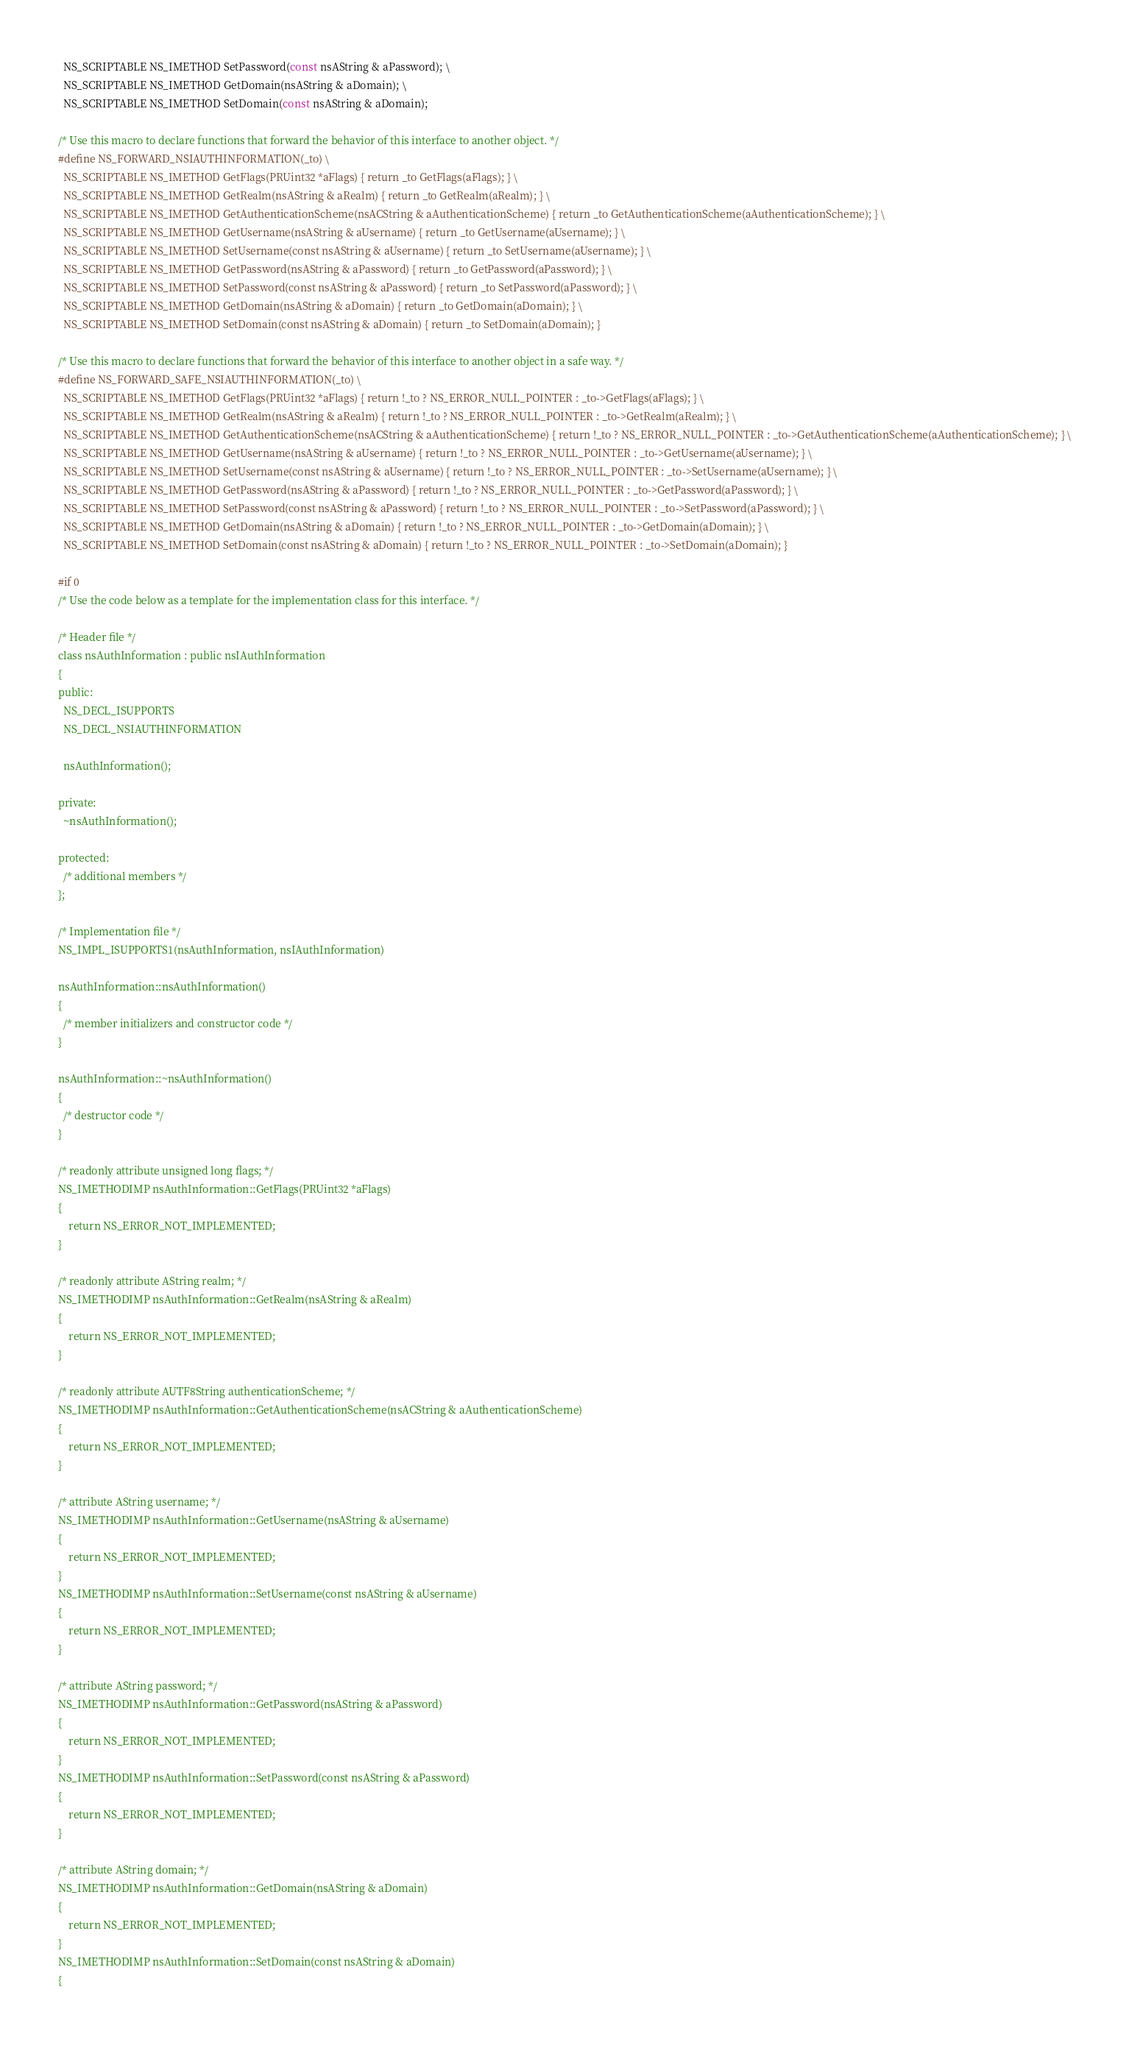Convert code to text. <code><loc_0><loc_0><loc_500><loc_500><_C_>  NS_SCRIPTABLE NS_IMETHOD SetPassword(const nsAString & aPassword); \
  NS_SCRIPTABLE NS_IMETHOD GetDomain(nsAString & aDomain); \
  NS_SCRIPTABLE NS_IMETHOD SetDomain(const nsAString & aDomain); 

/* Use this macro to declare functions that forward the behavior of this interface to another object. */
#define NS_FORWARD_NSIAUTHINFORMATION(_to) \
  NS_SCRIPTABLE NS_IMETHOD GetFlags(PRUint32 *aFlags) { return _to GetFlags(aFlags); } \
  NS_SCRIPTABLE NS_IMETHOD GetRealm(nsAString & aRealm) { return _to GetRealm(aRealm); } \
  NS_SCRIPTABLE NS_IMETHOD GetAuthenticationScheme(nsACString & aAuthenticationScheme) { return _to GetAuthenticationScheme(aAuthenticationScheme); } \
  NS_SCRIPTABLE NS_IMETHOD GetUsername(nsAString & aUsername) { return _to GetUsername(aUsername); } \
  NS_SCRIPTABLE NS_IMETHOD SetUsername(const nsAString & aUsername) { return _to SetUsername(aUsername); } \
  NS_SCRIPTABLE NS_IMETHOD GetPassword(nsAString & aPassword) { return _to GetPassword(aPassword); } \
  NS_SCRIPTABLE NS_IMETHOD SetPassword(const nsAString & aPassword) { return _to SetPassword(aPassword); } \
  NS_SCRIPTABLE NS_IMETHOD GetDomain(nsAString & aDomain) { return _to GetDomain(aDomain); } \
  NS_SCRIPTABLE NS_IMETHOD SetDomain(const nsAString & aDomain) { return _to SetDomain(aDomain); } 

/* Use this macro to declare functions that forward the behavior of this interface to another object in a safe way. */
#define NS_FORWARD_SAFE_NSIAUTHINFORMATION(_to) \
  NS_SCRIPTABLE NS_IMETHOD GetFlags(PRUint32 *aFlags) { return !_to ? NS_ERROR_NULL_POINTER : _to->GetFlags(aFlags); } \
  NS_SCRIPTABLE NS_IMETHOD GetRealm(nsAString & aRealm) { return !_to ? NS_ERROR_NULL_POINTER : _to->GetRealm(aRealm); } \
  NS_SCRIPTABLE NS_IMETHOD GetAuthenticationScheme(nsACString & aAuthenticationScheme) { return !_to ? NS_ERROR_NULL_POINTER : _to->GetAuthenticationScheme(aAuthenticationScheme); } \
  NS_SCRIPTABLE NS_IMETHOD GetUsername(nsAString & aUsername) { return !_to ? NS_ERROR_NULL_POINTER : _to->GetUsername(aUsername); } \
  NS_SCRIPTABLE NS_IMETHOD SetUsername(const nsAString & aUsername) { return !_to ? NS_ERROR_NULL_POINTER : _to->SetUsername(aUsername); } \
  NS_SCRIPTABLE NS_IMETHOD GetPassword(nsAString & aPassword) { return !_to ? NS_ERROR_NULL_POINTER : _to->GetPassword(aPassword); } \
  NS_SCRIPTABLE NS_IMETHOD SetPassword(const nsAString & aPassword) { return !_to ? NS_ERROR_NULL_POINTER : _to->SetPassword(aPassword); } \
  NS_SCRIPTABLE NS_IMETHOD GetDomain(nsAString & aDomain) { return !_to ? NS_ERROR_NULL_POINTER : _to->GetDomain(aDomain); } \
  NS_SCRIPTABLE NS_IMETHOD SetDomain(const nsAString & aDomain) { return !_to ? NS_ERROR_NULL_POINTER : _to->SetDomain(aDomain); } 

#if 0
/* Use the code below as a template for the implementation class for this interface. */

/* Header file */
class nsAuthInformation : public nsIAuthInformation
{
public:
  NS_DECL_ISUPPORTS
  NS_DECL_NSIAUTHINFORMATION

  nsAuthInformation();

private:
  ~nsAuthInformation();

protected:
  /* additional members */
};

/* Implementation file */
NS_IMPL_ISUPPORTS1(nsAuthInformation, nsIAuthInformation)

nsAuthInformation::nsAuthInformation()
{
  /* member initializers and constructor code */
}

nsAuthInformation::~nsAuthInformation()
{
  /* destructor code */
}

/* readonly attribute unsigned long flags; */
NS_IMETHODIMP nsAuthInformation::GetFlags(PRUint32 *aFlags)
{
    return NS_ERROR_NOT_IMPLEMENTED;
}

/* readonly attribute AString realm; */
NS_IMETHODIMP nsAuthInformation::GetRealm(nsAString & aRealm)
{
    return NS_ERROR_NOT_IMPLEMENTED;
}

/* readonly attribute AUTF8String authenticationScheme; */
NS_IMETHODIMP nsAuthInformation::GetAuthenticationScheme(nsACString & aAuthenticationScheme)
{
    return NS_ERROR_NOT_IMPLEMENTED;
}

/* attribute AString username; */
NS_IMETHODIMP nsAuthInformation::GetUsername(nsAString & aUsername)
{
    return NS_ERROR_NOT_IMPLEMENTED;
}
NS_IMETHODIMP nsAuthInformation::SetUsername(const nsAString & aUsername)
{
    return NS_ERROR_NOT_IMPLEMENTED;
}

/* attribute AString password; */
NS_IMETHODIMP nsAuthInformation::GetPassword(nsAString & aPassword)
{
    return NS_ERROR_NOT_IMPLEMENTED;
}
NS_IMETHODIMP nsAuthInformation::SetPassword(const nsAString & aPassword)
{
    return NS_ERROR_NOT_IMPLEMENTED;
}

/* attribute AString domain; */
NS_IMETHODIMP nsAuthInformation::GetDomain(nsAString & aDomain)
{
    return NS_ERROR_NOT_IMPLEMENTED;
}
NS_IMETHODIMP nsAuthInformation::SetDomain(const nsAString & aDomain)
{</code> 